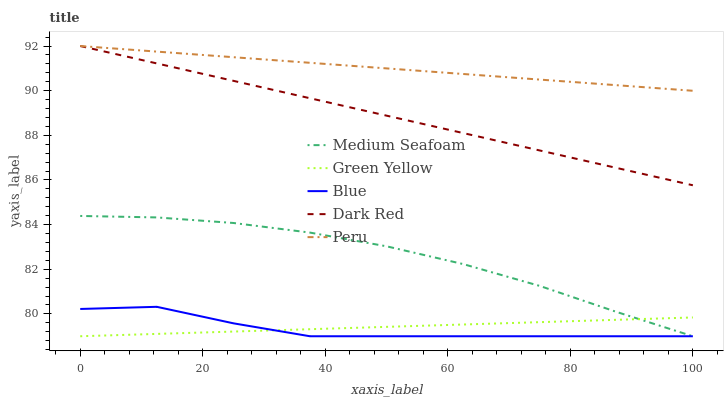Does Dark Red have the minimum area under the curve?
Answer yes or no. No. Does Dark Red have the maximum area under the curve?
Answer yes or no. No. Is Dark Red the smoothest?
Answer yes or no. No. Is Dark Red the roughest?
Answer yes or no. No. Does Dark Red have the lowest value?
Answer yes or no. No. Does Green Yellow have the highest value?
Answer yes or no. No. Is Medium Seafoam less than Peru?
Answer yes or no. Yes. Is Dark Red greater than Medium Seafoam?
Answer yes or no. Yes. Does Medium Seafoam intersect Peru?
Answer yes or no. No. 